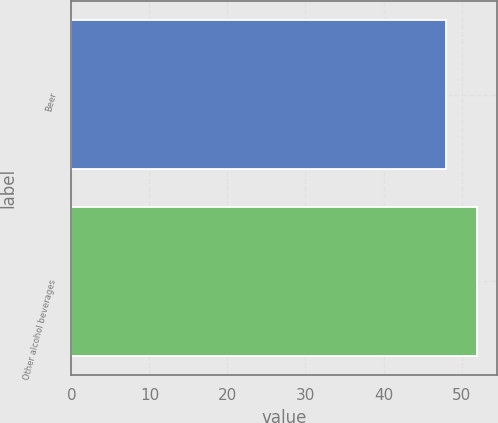Convert chart to OTSL. <chart><loc_0><loc_0><loc_500><loc_500><bar_chart><fcel>Beer<fcel>Other alcohol beverages<nl><fcel>48<fcel>52<nl></chart> 